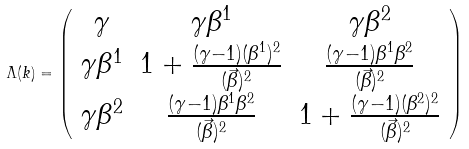Convert formula to latex. <formula><loc_0><loc_0><loc_500><loc_500>\Lambda ( k ) = \left ( \begin{array} { c c c } { \gamma } & { { { \gamma } { \beta } ^ { 1 } } } & { { { \gamma } { \beta } ^ { 2 } } } \\ { { { \gamma } { \beta } ^ { 1 } } } & { { 1 + \frac { ( { \gamma } - 1 ) ( { \beta } ^ { 1 } ) ^ { 2 } } { ( \vec { \beta } ) ^ { 2 } } } } & { { \frac { ( { \gamma } - 1 ) { \beta } ^ { 1 } { \beta } ^ { 2 } } { ( \vec { \beta } ) ^ { 2 } } } } \\ { { { \gamma } { \beta } ^ { 2 } } } & { { \frac { ( { \gamma } - 1 ) { \beta } ^ { 1 } { \beta } ^ { 2 } } { ( \vec { \beta } ) ^ { 2 } } } } & { { 1 + \frac { ( { \gamma } - 1 ) ( { \beta } ^ { 2 } ) ^ { 2 } } { ( \vec { \beta } ) ^ { 2 } } } } \end{array} \right )</formula> 